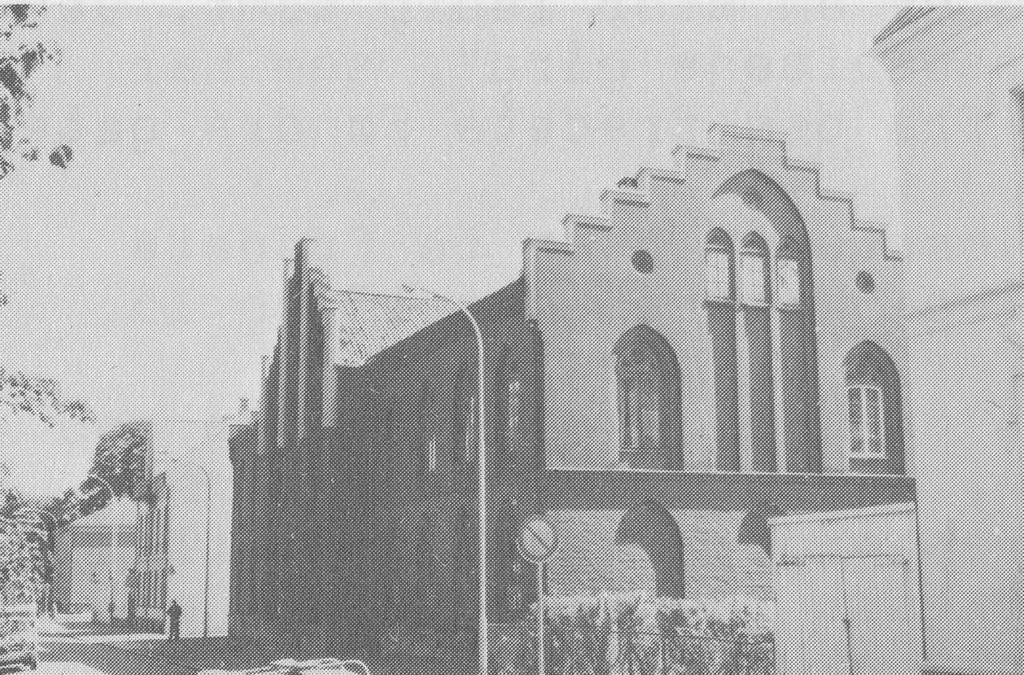What type of drawing is depicted in the image? The image is a sketch. What structures can be seen in the sketch? There are buildings in the sketch. What type of street furniture is present in the sketch? There are light poles in the sketch. What type of objects are present on the ground in the sketch? There are boards in the sketch. What type of transportation is visible on the road in the sketch? There are vehicles on the road in the sketch. What type of natural elements are present in the sketch? There are trees in the sketch. Are there any human figures in the sketch? Yes, there is a person in the sketch. What type of barrier is present in the sketch? There is a fence in the sketch. How many rings are visible on the person's fingers in the sketch? There are no rings visible on the person's fingers in the sketch. What type of hands are holding the building in the sketch? There are no hands holding the building in the sketch; the buildings are standing on their own. 